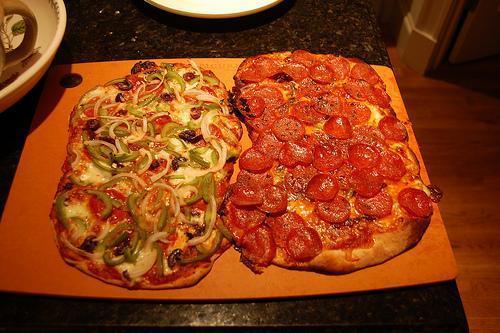How many pepperoni does the pizza on the left have ?
Give a very brief answer. 0. 